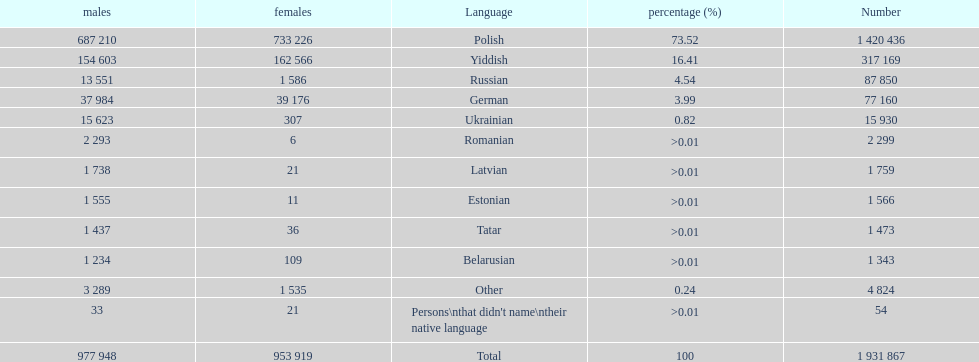Give me the full table as a dictionary. {'header': ['males', 'females', 'Language', 'percentage (%)', 'Number'], 'rows': [['687 210', '733 226', 'Polish', '73.52', '1 420 436'], ['154 603', '162 566', 'Yiddish', '16.41', '317 169'], ['13 551', '1 586', 'Russian', '4.54', '87 850'], ['37 984', '39 176', 'German', '3.99', '77 160'], ['15 623', '307', 'Ukrainian', '0.82', '15 930'], ['2 293', '6', 'Romanian', '>0.01', '2 299'], ['1 738', '21', 'Latvian', '>0.01', '1 759'], ['1 555', '11', 'Estonian', '>0.01', '1 566'], ['1 437', '36', 'Tatar', '>0.01', '1 473'], ['1 234', '109', 'Belarusian', '>0.01', '1 343'], ['3 289', '1 535', 'Other', '0.24', '4 824'], ['33', '21', "Persons\\nthat didn't name\\ntheir native language", '>0.01', '54'], ['977 948', '953 919', 'Total', '100', '1 931 867']]} Which language had the most number of people speaking it. Polish. 